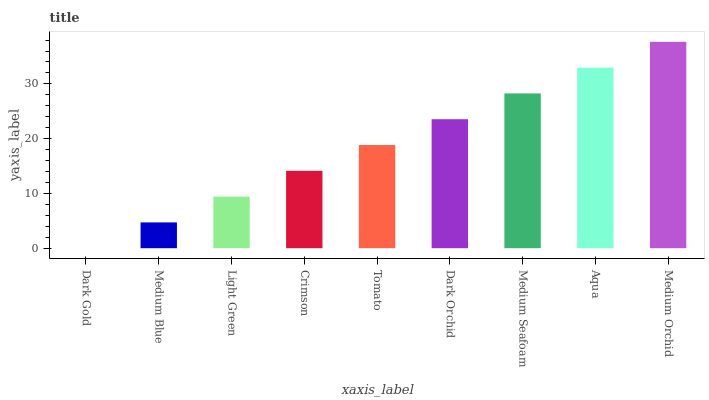Is Dark Gold the minimum?
Answer yes or no. Yes. Is Medium Orchid the maximum?
Answer yes or no. Yes. Is Medium Blue the minimum?
Answer yes or no. No. Is Medium Blue the maximum?
Answer yes or no. No. Is Medium Blue greater than Dark Gold?
Answer yes or no. Yes. Is Dark Gold less than Medium Blue?
Answer yes or no. Yes. Is Dark Gold greater than Medium Blue?
Answer yes or no. No. Is Medium Blue less than Dark Gold?
Answer yes or no. No. Is Tomato the high median?
Answer yes or no. Yes. Is Tomato the low median?
Answer yes or no. Yes. Is Dark Gold the high median?
Answer yes or no. No. Is Dark Orchid the low median?
Answer yes or no. No. 